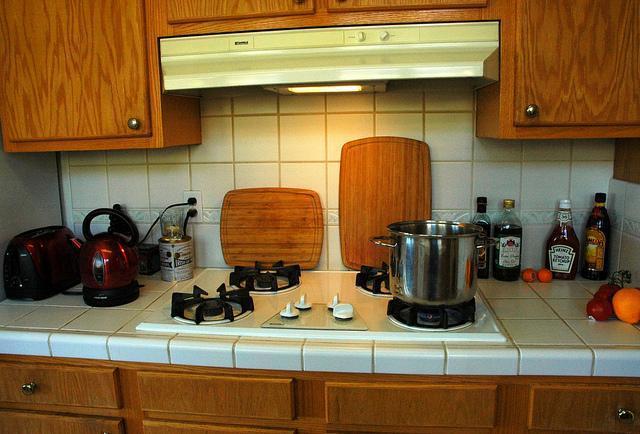How many bottles are visible?
Give a very brief answer. 2. How many toilets are there?
Give a very brief answer. 0. 